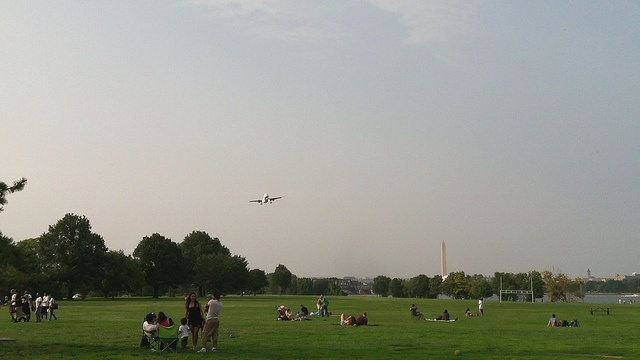Describe the objects in this image and their specific colors. I can see people in lightgray, darkgray, darkgreen, black, and gray tones, people in lightgray, black, darkgreen, and gray tones, people in lightgray, black, and gray tones, people in lightgray, black, darkgray, gray, and darkgreen tones, and people in lightgray, black, darkgreen, gray, and darkgray tones in this image. 